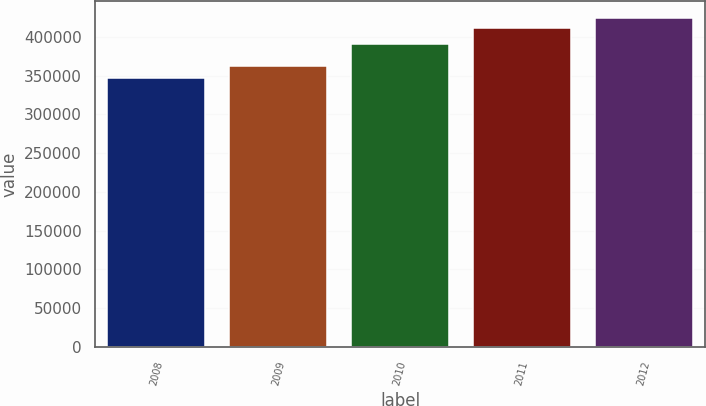<chart> <loc_0><loc_0><loc_500><loc_500><bar_chart><fcel>2008<fcel>2009<fcel>2010<fcel>2011<fcel>2012<nl><fcel>347000<fcel>363000<fcel>391000<fcel>412000<fcel>425000<nl></chart> 